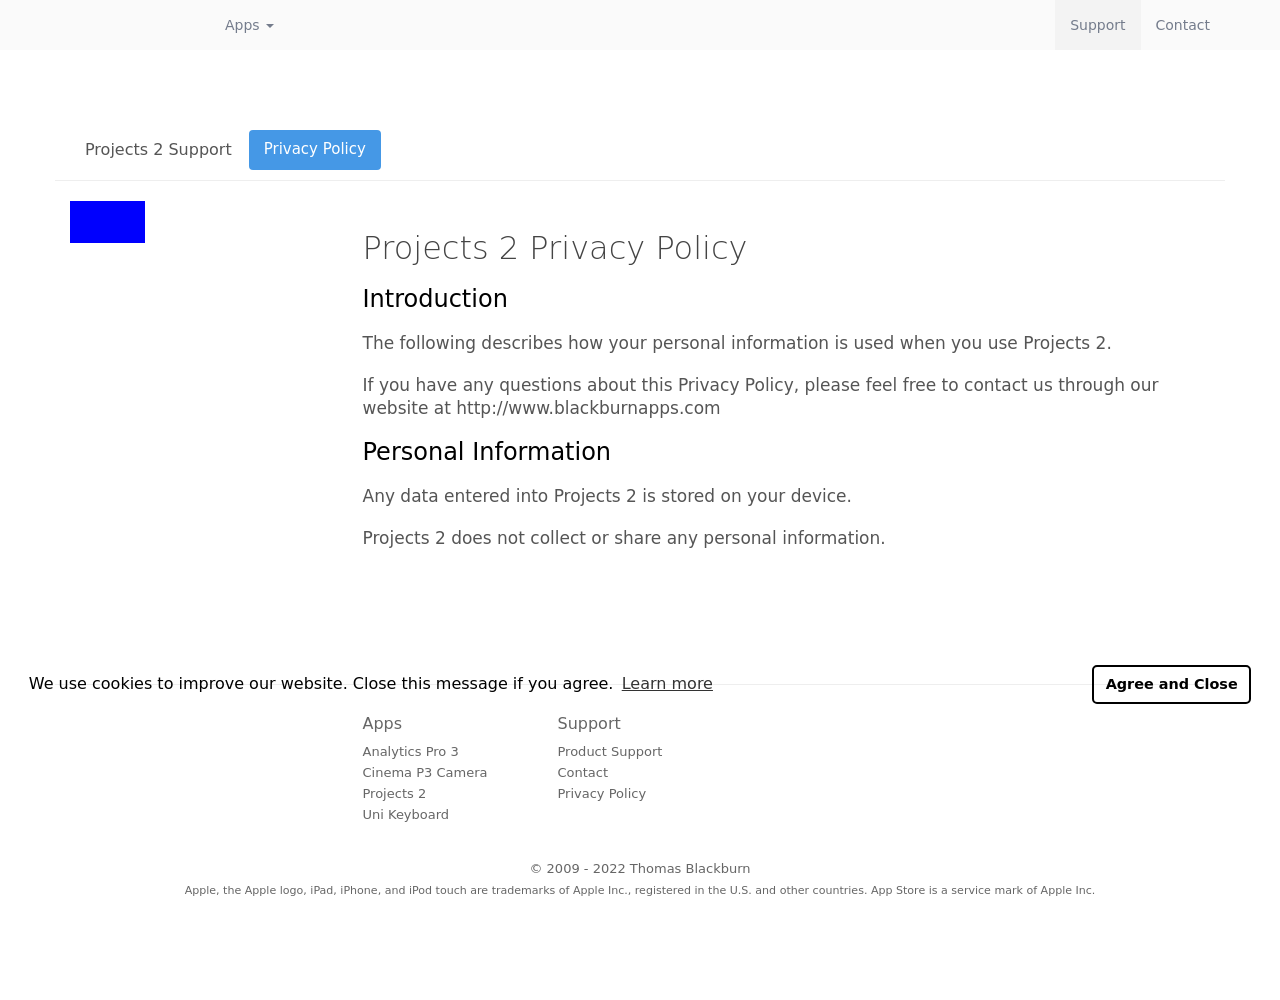Can you explain why there's a focus on privacy in this image? The focus on privacy highlighted in the image is paramount due to the nature of the application, Projects 2, which handles personal projects and data storage on user devices. The attention to privacy policies ensures users that their data is managed responsibly and remains confidential, enhancing user trust and application credibility. 